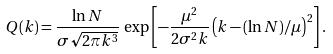<formula> <loc_0><loc_0><loc_500><loc_500>Q ( k ) = \frac { \ln N } { \sigma \sqrt { 2 \pi k ^ { 3 } } } \, \exp \left [ - \frac { \mu ^ { 2 } } { 2 \sigma ^ { 2 } k } \left ( k - ( \ln N ) / \mu \right ) ^ { 2 } \right ] .</formula> 